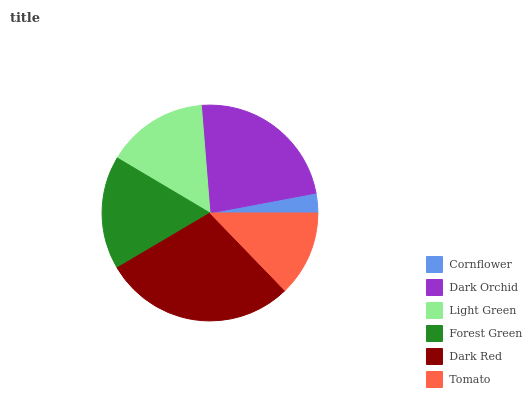Is Cornflower the minimum?
Answer yes or no. Yes. Is Dark Red the maximum?
Answer yes or no. Yes. Is Dark Orchid the minimum?
Answer yes or no. No. Is Dark Orchid the maximum?
Answer yes or no. No. Is Dark Orchid greater than Cornflower?
Answer yes or no. Yes. Is Cornflower less than Dark Orchid?
Answer yes or no. Yes. Is Cornflower greater than Dark Orchid?
Answer yes or no. No. Is Dark Orchid less than Cornflower?
Answer yes or no. No. Is Forest Green the high median?
Answer yes or no. Yes. Is Light Green the low median?
Answer yes or no. Yes. Is Dark Orchid the high median?
Answer yes or no. No. Is Dark Red the low median?
Answer yes or no. No. 